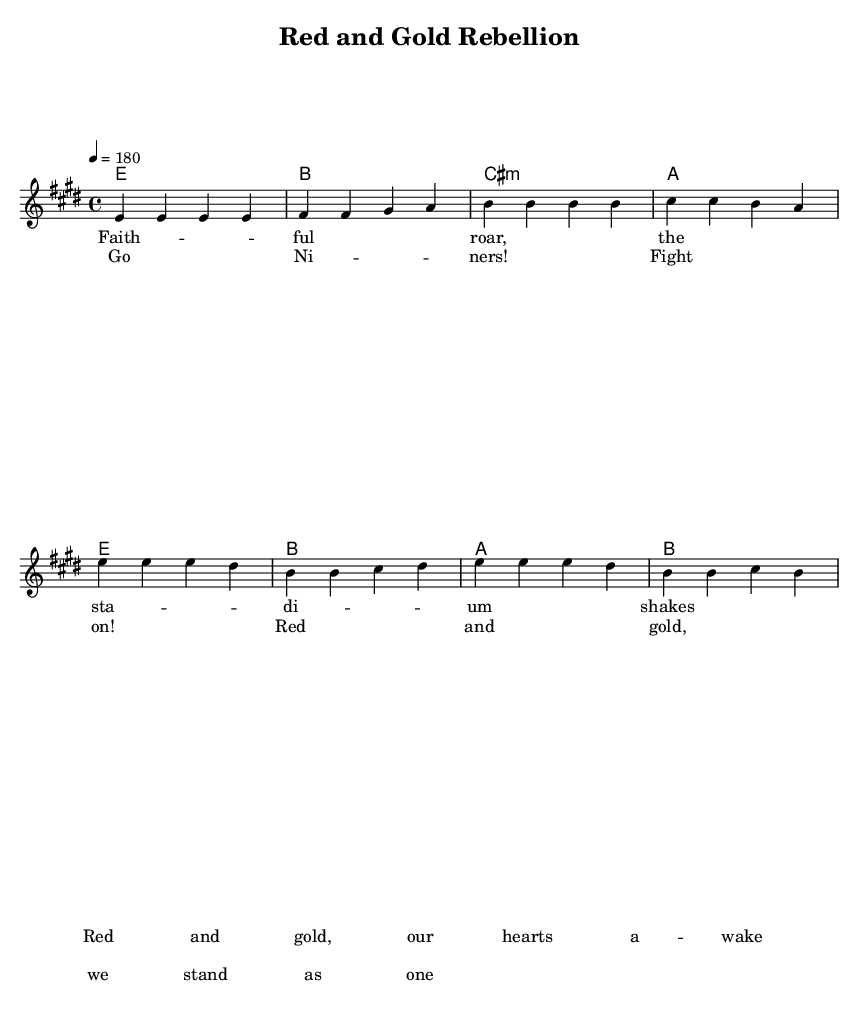What is the key signature of this music? The key signature is indicated by the presence of sharp notes. Here, it has four sharps, indicating the key of E major.
Answer: E major What is the time signature of this music? The time signature is indicated at the beginning of the sheet music, denoting how many beats are in each measure. Here, the time signature is 4/4, which means there are four beats in each measure.
Answer: 4/4 What is the tempo of the piece? The tempo is indicated by the marking '4 = 180' in the score, which means the quarter note gets a beat at 180 beats per minute.
Answer: 180 How many measures are in the verse section? The verse section consists of four lines of music, each line representing one measure. Counting the measures, there are a total of 4 measures in the verse.
Answer: 4 What is the first line of the lyrics in the verse section? The first line of lyrics in the verse section is the first set of lyrics provided, which describes the faithful roar and the stadium shaking, specifically, "Faithful roar, the stadium shakes."
Answer: Faithful roar, the stadium shakes How is the chorus structured compared to the verse? The chorus is structured with a different melodic and harmonic pattern than the verse. The verse has a more narrative-like structure, while the chorus is more emphatic and rallying, emphasizing the team spirit with "Go Niners! Fight on!"
Answer: More emphatic 